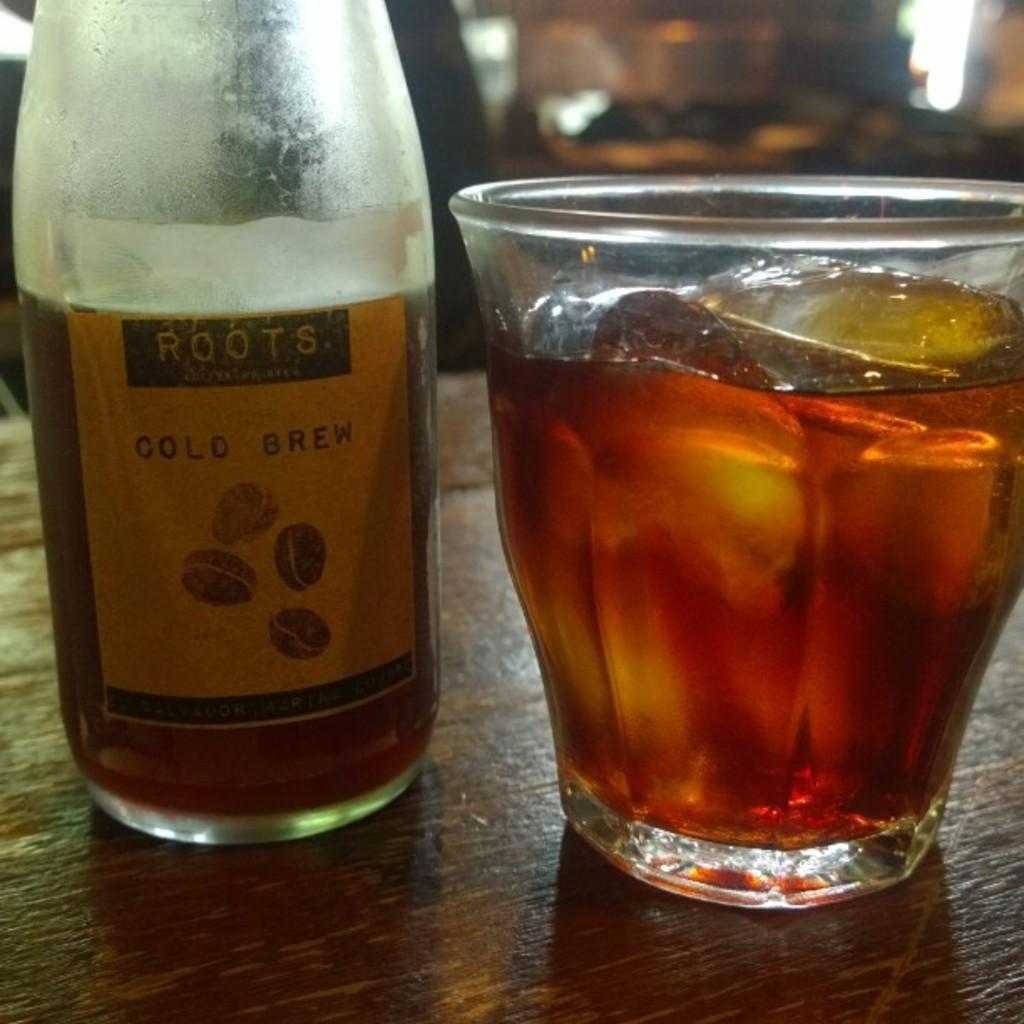Could you give a brief overview of what you see in this image? This picture is mainly highlighted with a bottle , beside to it we can see a glass with drink and ice cubes init on the table. 